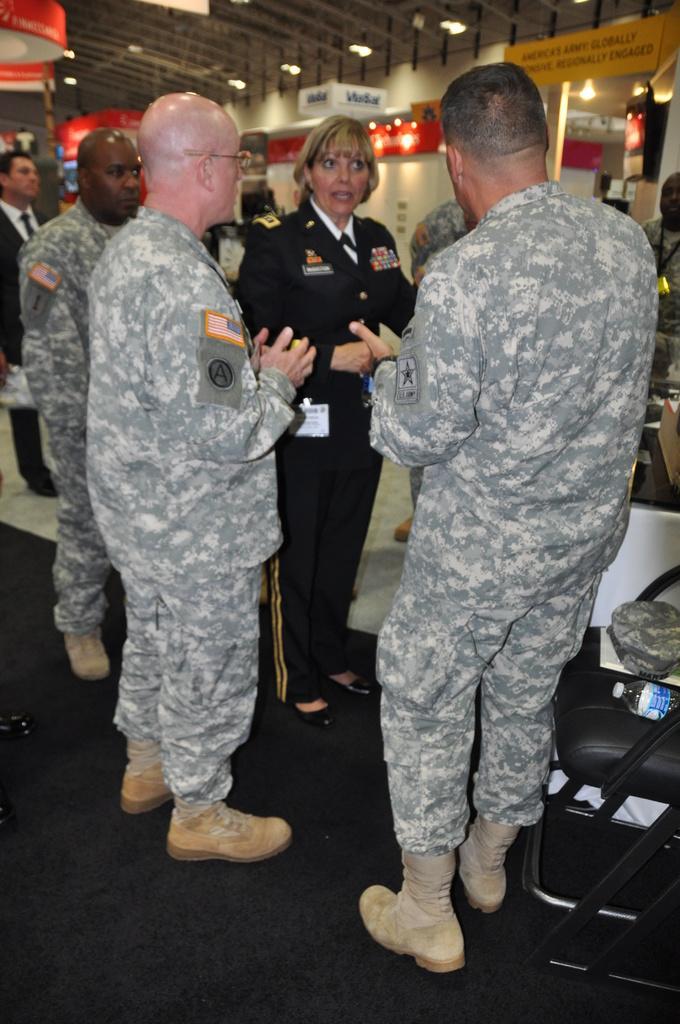Describe this image in one or two sentences. In this picture I can see few people are standing and looks like they are speaking to each other and I can see a cap and a bottle on the chair and I can see few boards with some text and few lights on the ceiling. 